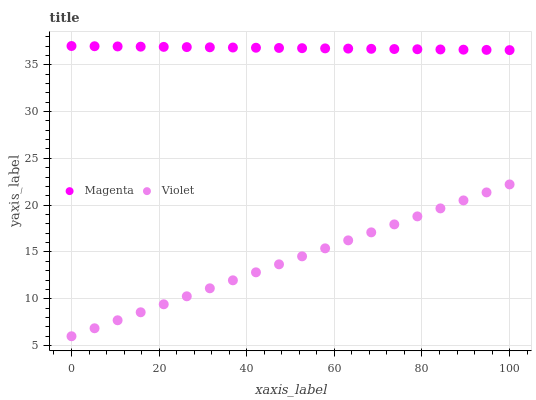Does Violet have the minimum area under the curve?
Answer yes or no. Yes. Does Magenta have the maximum area under the curve?
Answer yes or no. Yes. Does Violet have the maximum area under the curve?
Answer yes or no. No. Is Magenta the smoothest?
Answer yes or no. Yes. Is Violet the roughest?
Answer yes or no. Yes. Is Violet the smoothest?
Answer yes or no. No. Does Violet have the lowest value?
Answer yes or no. Yes. Does Magenta have the highest value?
Answer yes or no. Yes. Does Violet have the highest value?
Answer yes or no. No. Is Violet less than Magenta?
Answer yes or no. Yes. Is Magenta greater than Violet?
Answer yes or no. Yes. Does Violet intersect Magenta?
Answer yes or no. No. 